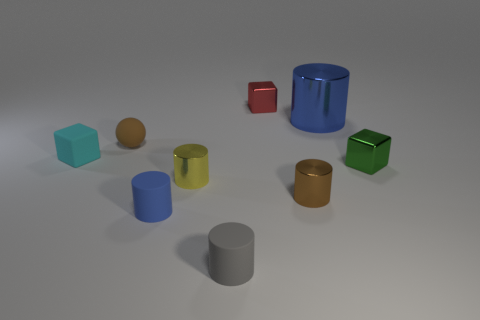Subtract all gray rubber cylinders. How many cylinders are left? 4 Subtract all purple spheres. How many blue cylinders are left? 2 Subtract 2 cylinders. How many cylinders are left? 3 Subtract all gray cylinders. How many cylinders are left? 4 Subtract all blocks. How many objects are left? 6 Add 9 big cyan things. How many big cyan things exist? 9 Subtract 0 green cylinders. How many objects are left? 9 Subtract all red blocks. Subtract all blue spheres. How many blocks are left? 2 Subtract all big cylinders. Subtract all small cyan objects. How many objects are left? 7 Add 3 tiny blue rubber things. How many tiny blue rubber things are left? 4 